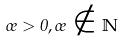<formula> <loc_0><loc_0><loc_500><loc_500>\sigma > 0 , \sigma \notin \mathbb { N }</formula> 